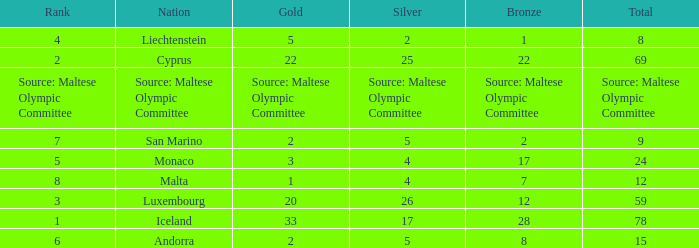How many bronze medals does the nation ranked number 1 have? 28.0. 